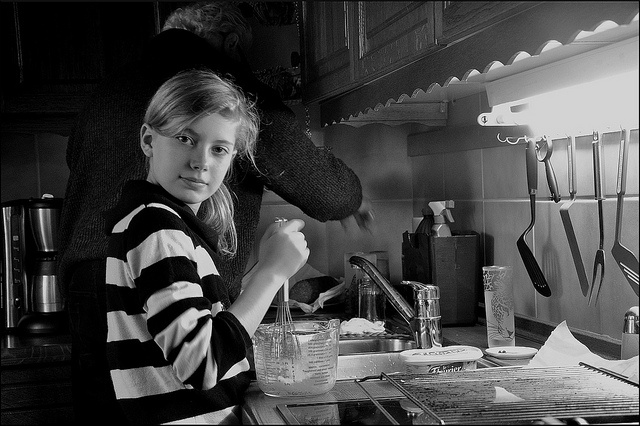Describe the objects in this image and their specific colors. I can see people in black, darkgray, gray, and lightgray tones, people in black, gray, and lightgray tones, bowl in black, darkgray, gray, and lightgray tones, sink in black, gray, darkgray, and lightgray tones, and cup in black, gray, and lightgray tones in this image. 